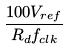Convert formula to latex. <formula><loc_0><loc_0><loc_500><loc_500>\frac { 1 0 0 V _ { r e f } } { R _ { d } f _ { c l k } }</formula> 